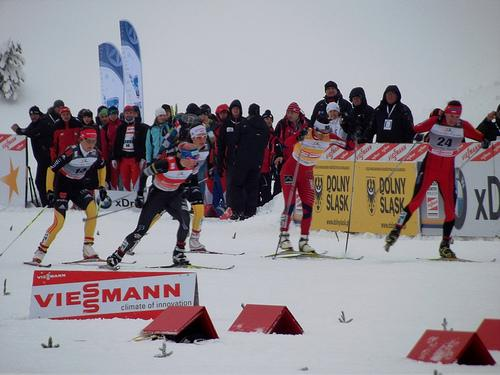Provide a description of the scene involving the skiers. Several skiers are racing down a snow-covered hill, wearing colorful outfits and holding ski poles, as spectators watch from behind. Mention a detail about the ski slope in the image. The ski slope is covered in white snow. Which company has an advertisement in the image? BMW has a white advertisement. Name the specific number on one of the skiers and their outfit colors. Skier number 24 is wearing red and white clothing. Describe the scene involving the spectators in the image. A group of people are watching the skiers competing, standing behind them on a snow-covered ground with banners and signs around. Identify the competition taking place in the image. Ski competition with multiple skiers racing down the slope. Select a task and briefly explain the referential expression grounding involved in it. In the task "identifying the color and nature of the sign in the snow", the referential expression "the sign in the snow" grounds to the white and red business promotional sign. What is the color and nature of the sign in the snow? The sign is white and red, and it is a business promotional sign. List the colors of the ski poles held by one skier. The skier holds two snow poles that are yellow, black, and white. Describe the headwear of one skier in the image. One skier is wearing a red headband. 